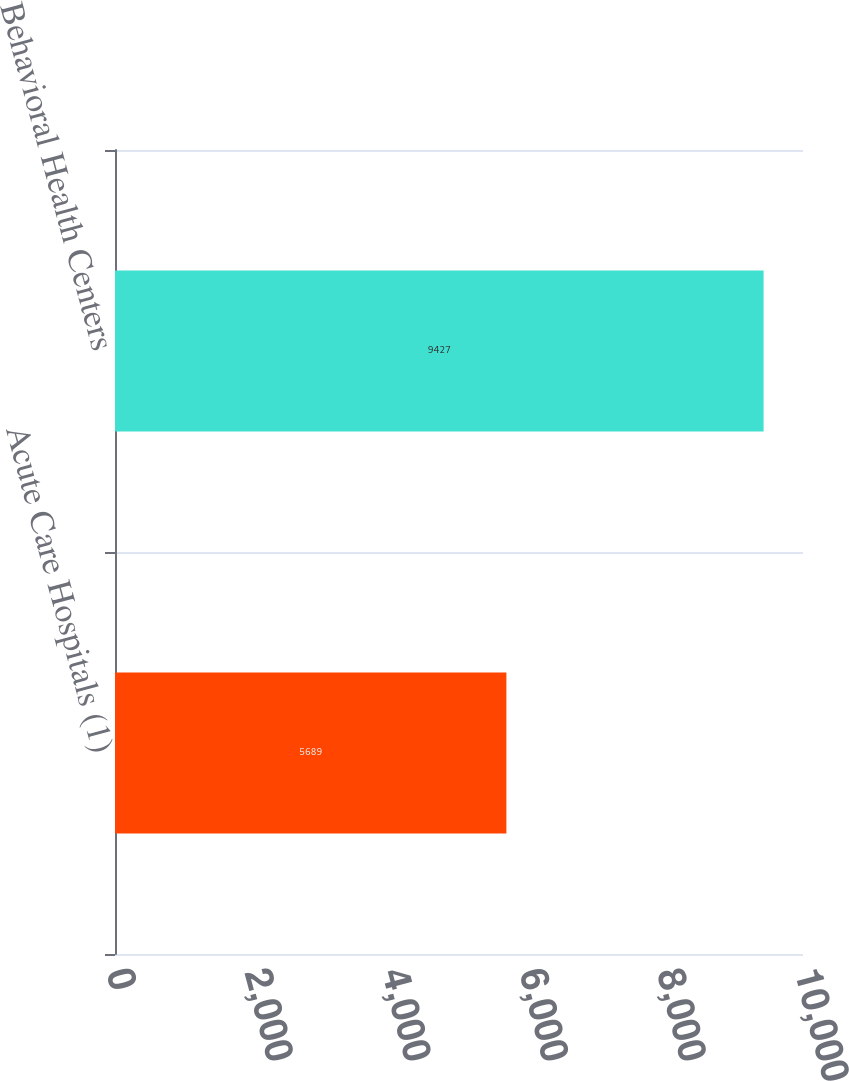Convert chart to OTSL. <chart><loc_0><loc_0><loc_500><loc_500><bar_chart><fcel>Acute Care Hospitals (1)<fcel>Behavioral Health Centers<nl><fcel>5689<fcel>9427<nl></chart> 